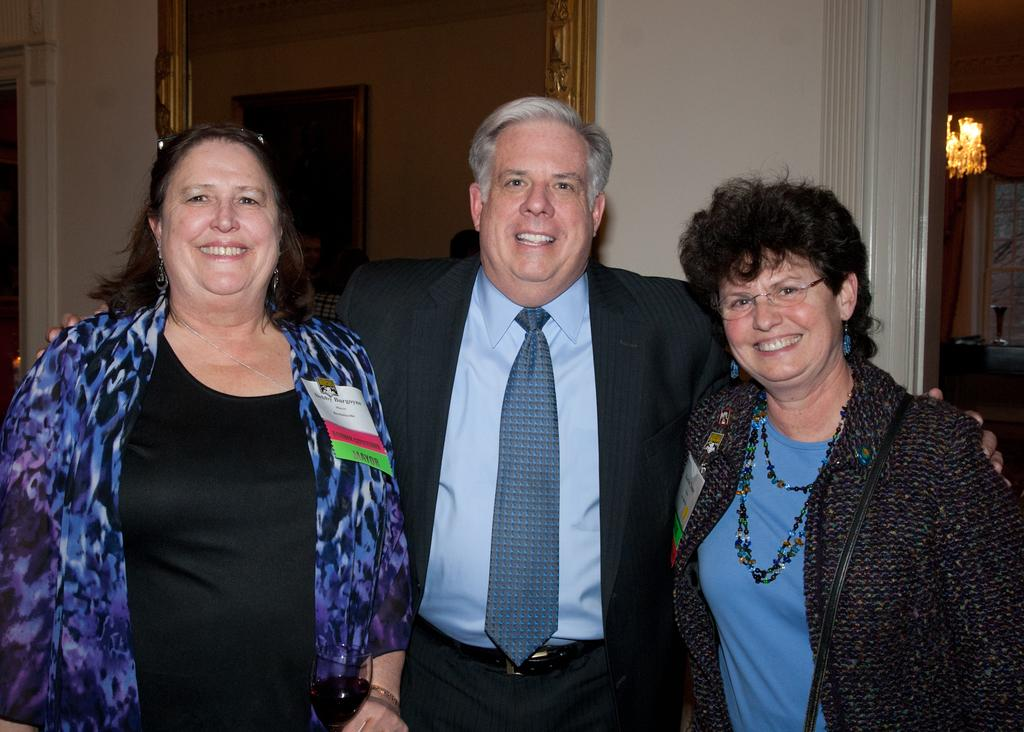How many people are in the image? There are three persons standing in the image. What is the facial expression of the persons in the image? The persons are smiling. What can be seen in the background of the image? There is a door and a wall in the background of the image. What is hanging on the wall in the image? There is a photo frame on the wall. What is the source of light in the image? There is a light in the image. What type of feather can be seen on the person's head in the image? There is no feather present on anyone's head in the image. What type of office furniture can be seen in the image? There is no office furniture present in the image. 